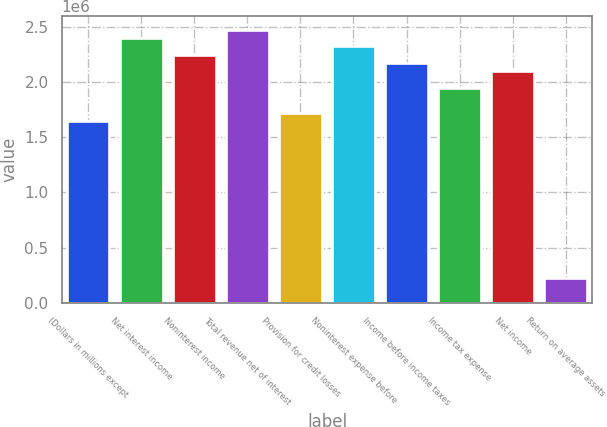Convert chart to OTSL. <chart><loc_0><loc_0><loc_500><loc_500><bar_chart><fcel>(Dollars in millions except<fcel>Net interest income<fcel>Noninterest income<fcel>Total revenue net of interest<fcel>Provision for credit losses<fcel>Noninterest expense before<fcel>Income before income taxes<fcel>Income tax expense<fcel>Net income<fcel>Return on average assets<nl><fcel>1.64803e+06<fcel>2.39713e+06<fcel>2.24731e+06<fcel>2.47204e+06<fcel>1.72294e+06<fcel>2.32222e+06<fcel>2.1724e+06<fcel>1.94767e+06<fcel>2.09749e+06<fcel>224732<nl></chart> 